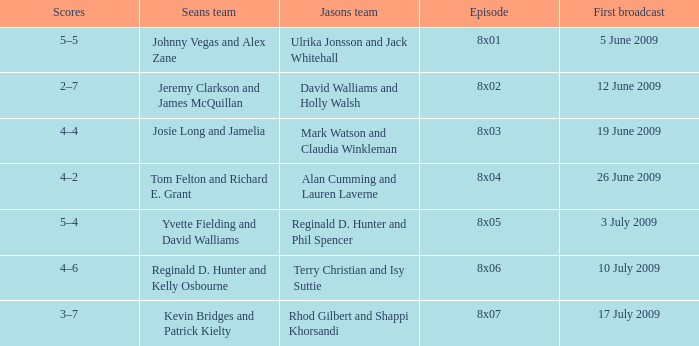What is the broadcast date where Jason's team is Rhod Gilbert and Shappi Khorsandi? 17 July 2009. 